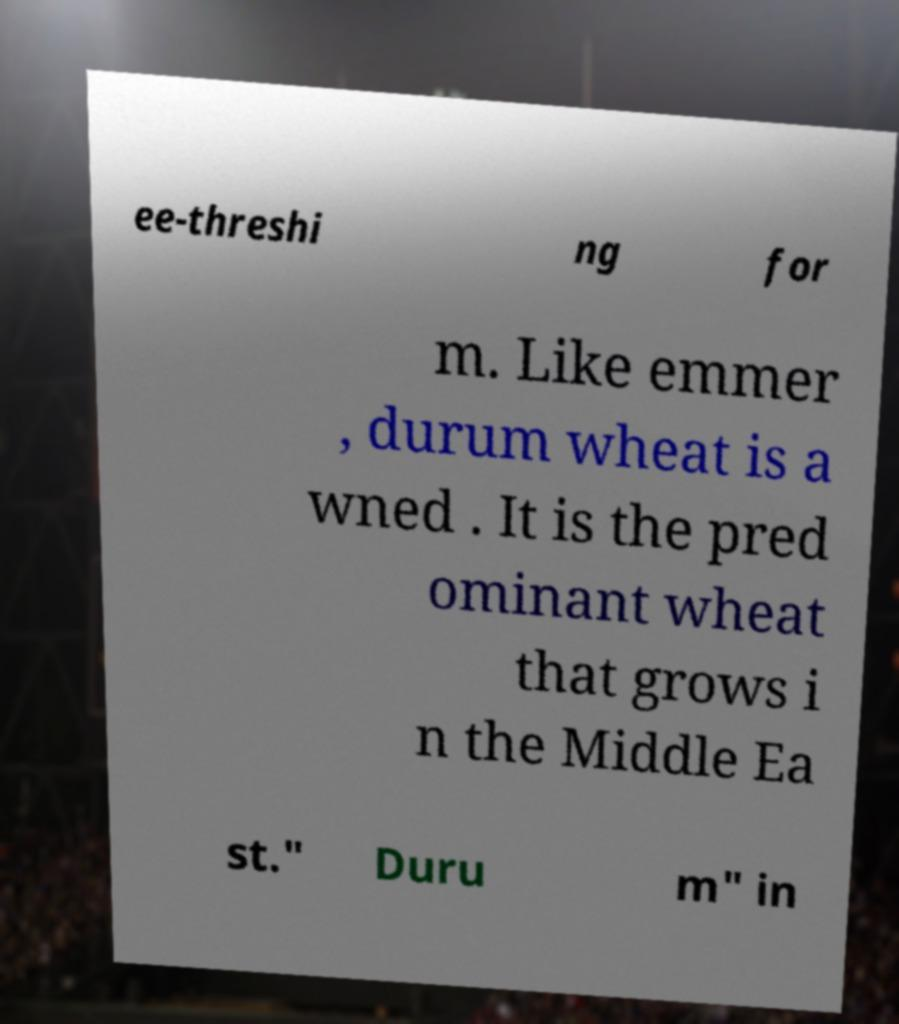For documentation purposes, I need the text within this image transcribed. Could you provide that? ee-threshi ng for m. Like emmer , durum wheat is a wned . It is the pred ominant wheat that grows i n the Middle Ea st." Duru m" in 